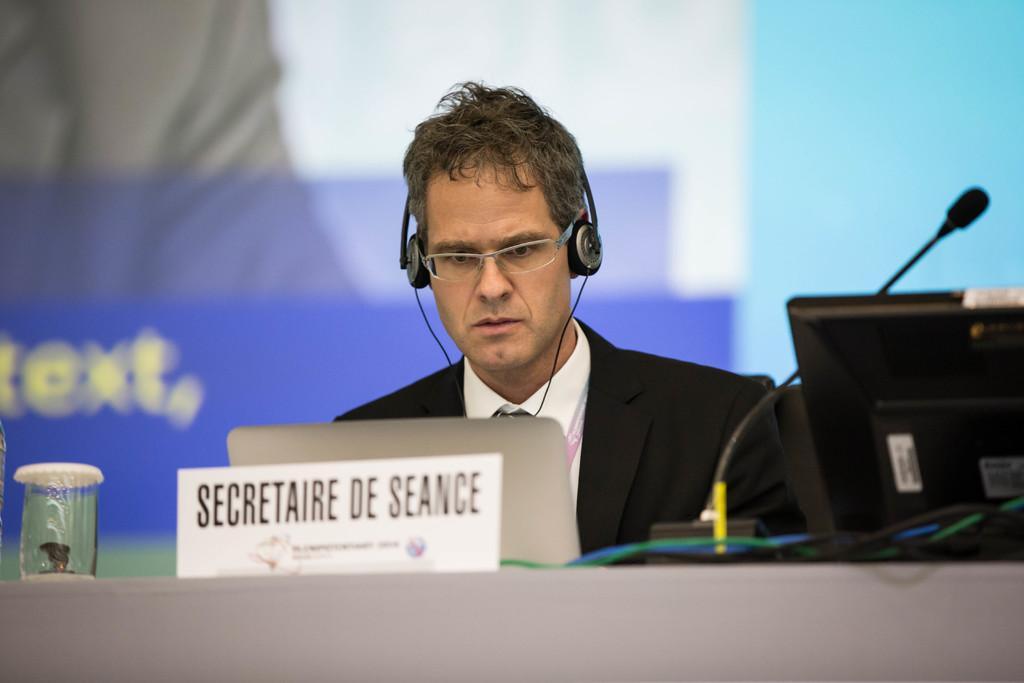Can you describe this image briefly? In this image I can see the person wearing the black and white color dress. In-front of the person I can see the systems, boards, mic and the glass. In the background I can see the screen. 